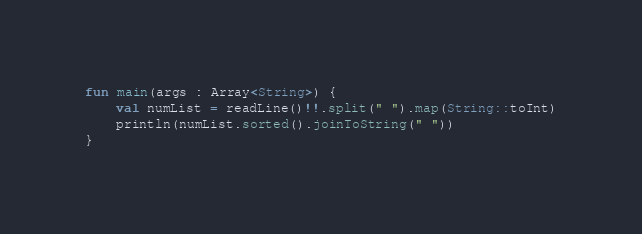Convert code to text. <code><loc_0><loc_0><loc_500><loc_500><_Kotlin_>fun main(args : Array<String>) {
    val numList = readLine()!!.split(" ").map(String::toInt)
    println(numList.sorted().joinToString(" "))
}

</code> 